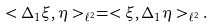<formula> <loc_0><loc_0><loc_500><loc_500>< \Delta _ { 1 } \xi , \eta > _ { \ell ^ { 2 } } = < \xi , \Delta _ { 1 } \eta > _ { \ell ^ { 2 } } .</formula> 